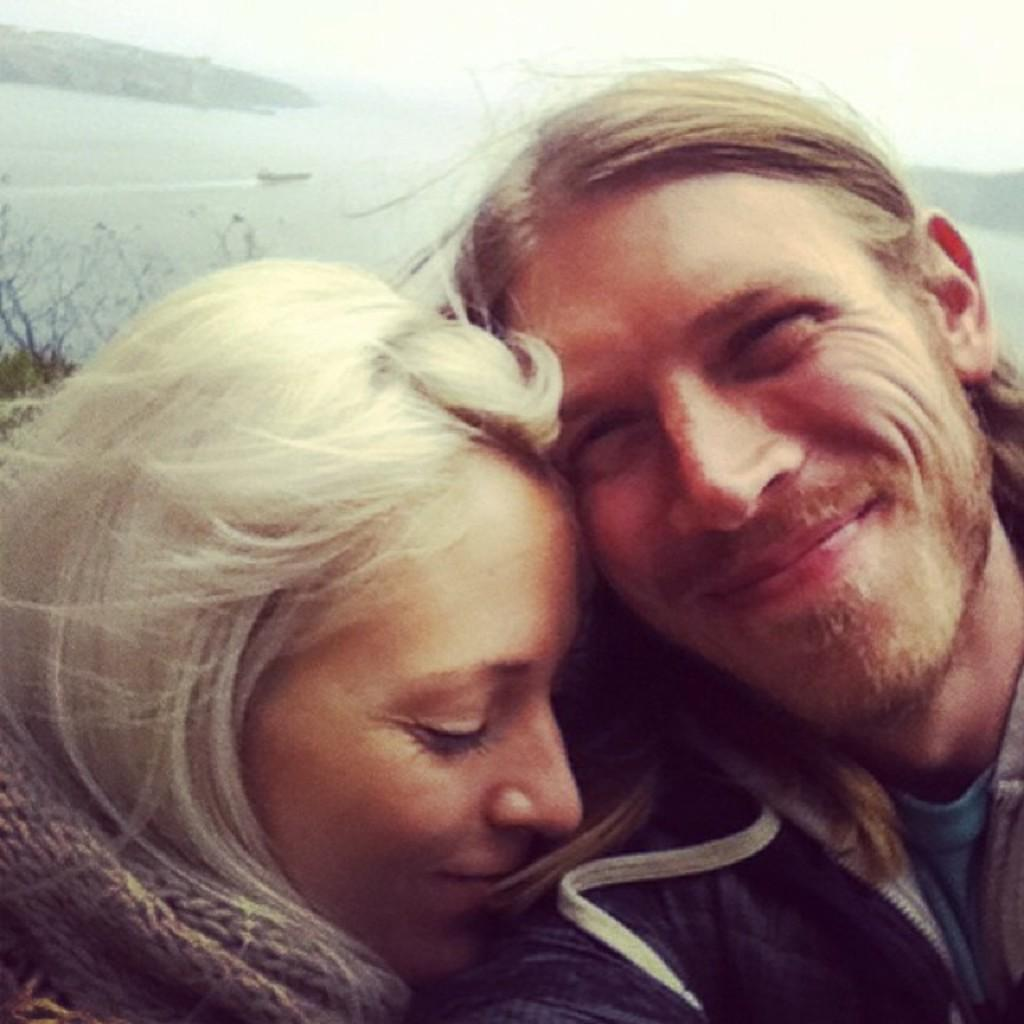How many people are in the image? There are two people in the image, a man and a woman. What are the expressions on their faces? Both the man and the woman are smiling. What can be seen in the background of the image? There are hills visible in the background of the image. What is located in the water in the image? There is a boat in the water in the image. What type of vegetation is visible in the image? There are plants visible in the image. What type of fuel is being used by the boat in the image? There is no information about the boat's fuel in the image, and therefore it cannot be determined. Can you tell me where the drawer is located in the image? There is no drawer present in the image. 